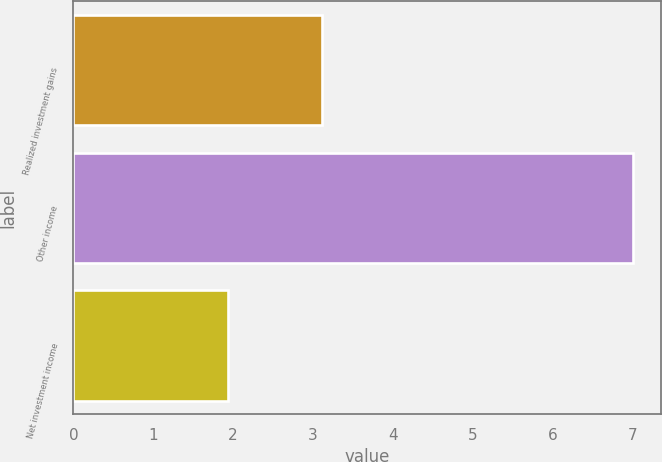<chart> <loc_0><loc_0><loc_500><loc_500><bar_chart><fcel>Realized investment gains<fcel>Other income<fcel>Net investment income<nl><fcel>3.11<fcel>7<fcel>1.94<nl></chart> 